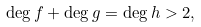Convert formula to latex. <formula><loc_0><loc_0><loc_500><loc_500>\deg f + \deg g = \deg h > 2 ,</formula> 